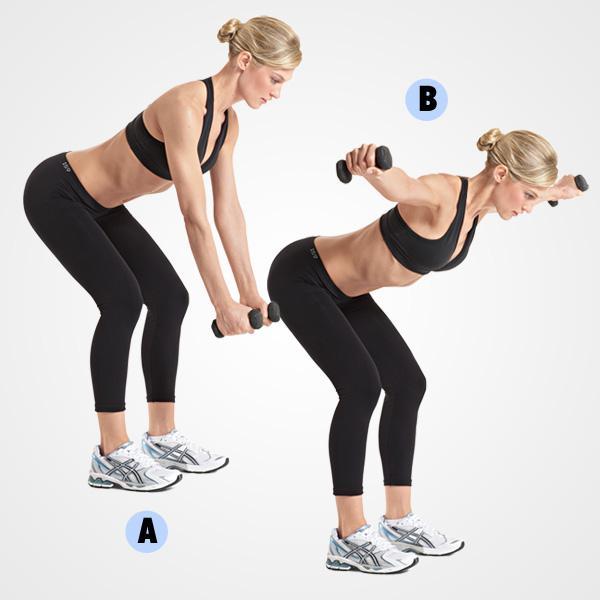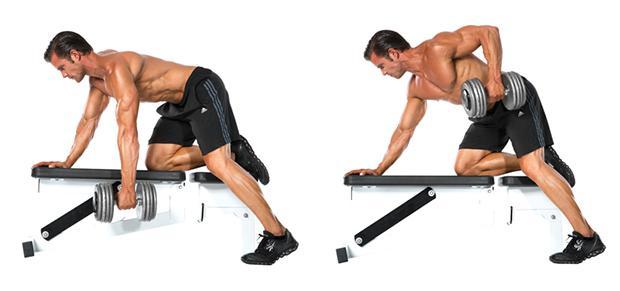The first image is the image on the left, the second image is the image on the right. Considering the images on both sides, is "There is only one man in at least one image." valid? Answer yes or no. No. 